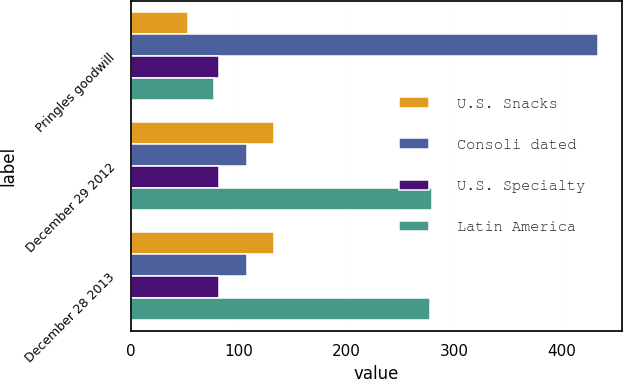Convert chart. <chart><loc_0><loc_0><loc_500><loc_500><stacked_bar_chart><ecel><fcel>Pringles goodwill<fcel>December 29 2012<fcel>December 28 2013<nl><fcel>U.S. Snacks<fcel>53<fcel>133<fcel>133<nl><fcel>Consoli dated<fcel>434<fcel>107.5<fcel>107.5<nl><fcel>U.S. Specialty<fcel>82<fcel>82<fcel>82<nl><fcel>Latin America<fcel>77<fcel>280<fcel>278<nl></chart> 